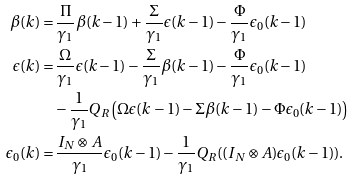Convert formula to latex. <formula><loc_0><loc_0><loc_500><loc_500>\beta ( k ) = & \, \frac { \Pi } { \gamma _ { 1 } } \beta ( k - 1 ) + \frac { \Sigma } { \gamma _ { 1 } } \epsilon ( k - 1 ) - \frac { \Phi } { \gamma _ { 1 } } \epsilon _ { 0 } ( k - 1 ) \\ \epsilon ( k ) = & \, \frac { \Omega } { \gamma _ { 1 } } \epsilon ( k - 1 ) - \frac { \Sigma } { \gamma _ { 1 } } \beta ( k - 1 ) - \frac { \Phi } { \gamma _ { 1 } } \epsilon _ { 0 } ( k - 1 ) \\ & - \frac { 1 } { \gamma _ { 1 } } Q _ { R } \left ( \Omega \epsilon ( k - 1 ) - \Sigma \beta ( k - 1 ) - \Phi \epsilon _ { 0 } ( k - 1 ) \right ) \\ \epsilon _ { 0 } ( k ) = & \, \frac { I _ { N } \otimes A } { \gamma _ { 1 } } \epsilon _ { 0 } ( k - 1 ) - \frac { 1 } { \gamma _ { 1 } } Q _ { R } ( ( I _ { N } \otimes A ) \epsilon _ { 0 } ( k - 1 ) ) .</formula> 